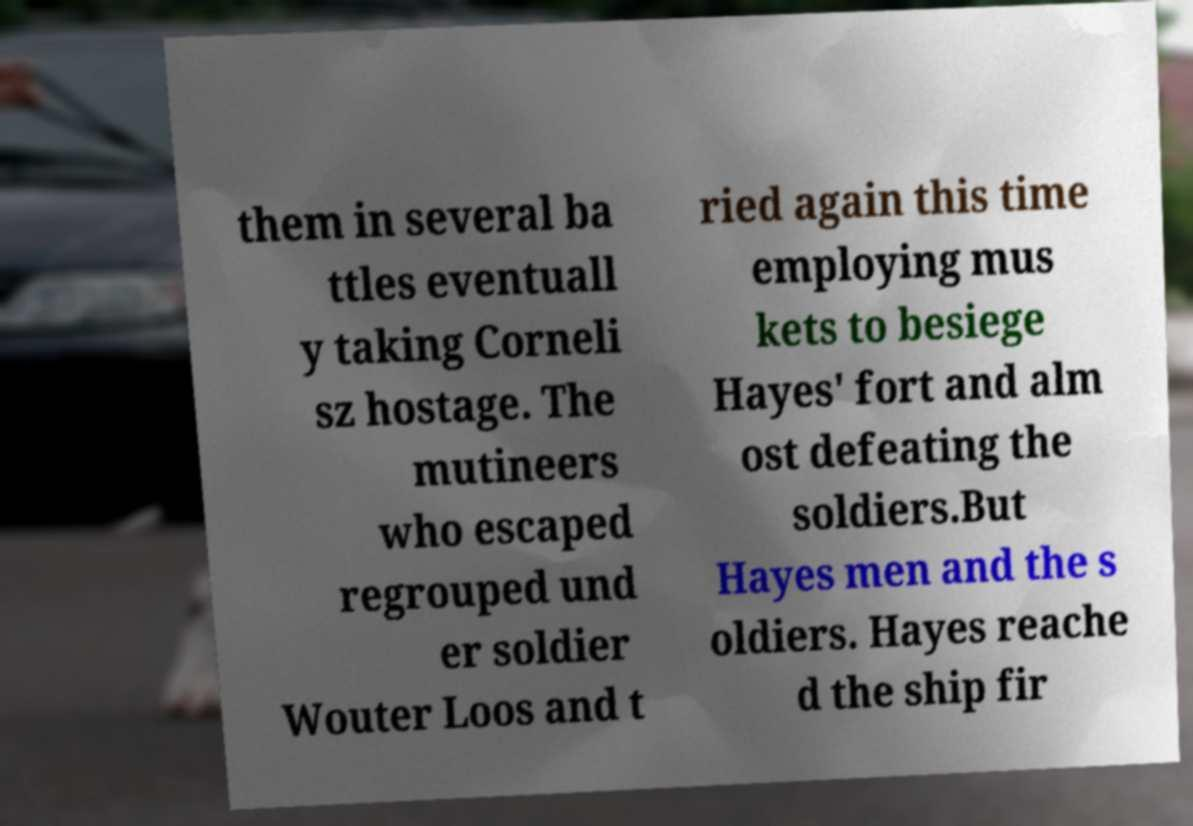Could you assist in decoding the text presented in this image and type it out clearly? them in several ba ttles eventuall y taking Corneli sz hostage. The mutineers who escaped regrouped und er soldier Wouter Loos and t ried again this time employing mus kets to besiege Hayes' fort and alm ost defeating the soldiers.But Hayes men and the s oldiers. Hayes reache d the ship fir 